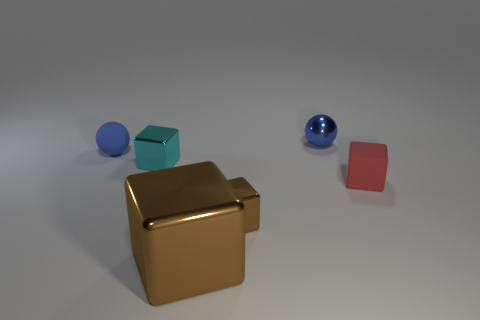Subtract all tiny cyan metallic cubes. How many cubes are left? 3 Add 2 small gray shiny things. How many objects exist? 8 Subtract all blocks. How many objects are left? 2 Subtract all red balls. How many brown blocks are left? 2 Subtract all red blocks. How many blocks are left? 3 Subtract all purple blocks. Subtract all yellow cylinders. How many blocks are left? 4 Add 2 matte spheres. How many matte spheres exist? 3 Subtract 1 cyan blocks. How many objects are left? 5 Subtract 3 cubes. How many cubes are left? 1 Subtract all cyan blocks. Subtract all small blue cubes. How many objects are left? 5 